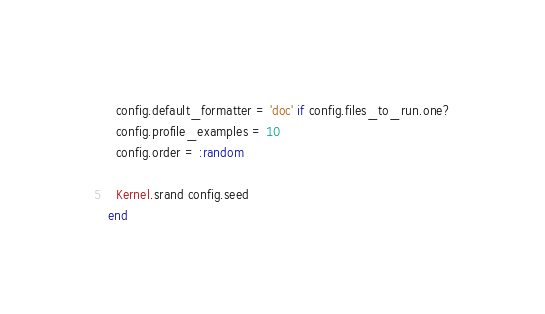Convert code to text. <code><loc_0><loc_0><loc_500><loc_500><_Ruby_>  config.default_formatter = 'doc' if config.files_to_run.one?
  config.profile_examples = 10
  config.order = :random

  Kernel.srand config.seed
end
</code> 